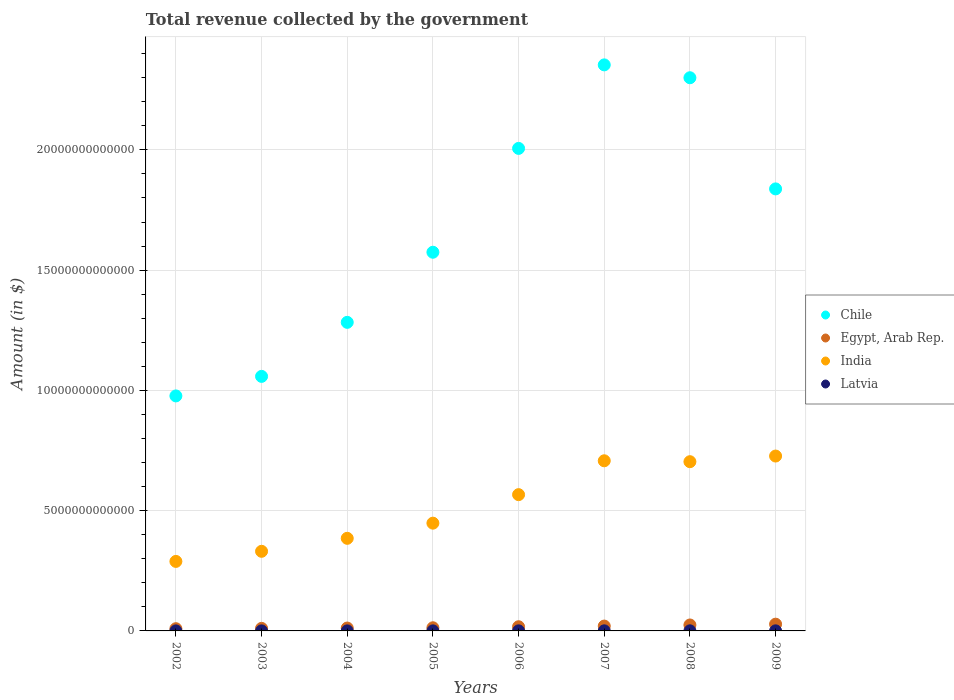How many different coloured dotlines are there?
Provide a short and direct response. 4. Is the number of dotlines equal to the number of legend labels?
Offer a very short reply. Yes. What is the total revenue collected by the government in Latvia in 2009?
Give a very brief answer. 3.39e+09. Across all years, what is the maximum total revenue collected by the government in Egypt, Arab Rep.?
Provide a succinct answer. 2.81e+11. Across all years, what is the minimum total revenue collected by the government in India?
Offer a very short reply. 2.89e+12. In which year was the total revenue collected by the government in Chile maximum?
Give a very brief answer. 2007. What is the total total revenue collected by the government in Egypt, Arab Rep. in the graph?
Your answer should be compact. 1.35e+12. What is the difference between the total revenue collected by the government in Egypt, Arab Rep. in 2002 and that in 2005?
Your response must be concise. -3.85e+1. What is the difference between the total revenue collected by the government in Latvia in 2002 and the total revenue collected by the government in Egypt, Arab Rep. in 2003?
Offer a terse response. -1.05e+11. What is the average total revenue collected by the government in Egypt, Arab Rep. per year?
Your answer should be very brief. 1.69e+11. In the year 2008, what is the difference between the total revenue collected by the government in Egypt, Arab Rep. and total revenue collected by the government in India?
Provide a short and direct response. -6.79e+12. What is the ratio of the total revenue collected by the government in Chile in 2002 to that in 2003?
Provide a succinct answer. 0.92. What is the difference between the highest and the second highest total revenue collected by the government in India?
Provide a short and direct response. 1.97e+11. What is the difference between the highest and the lowest total revenue collected by the government in Chile?
Offer a terse response. 1.38e+13. Is the sum of the total revenue collected by the government in Latvia in 2005 and 2008 greater than the maximum total revenue collected by the government in Chile across all years?
Ensure brevity in your answer.  No. Does the total revenue collected by the government in India monotonically increase over the years?
Make the answer very short. No. How many dotlines are there?
Ensure brevity in your answer.  4. What is the difference between two consecutive major ticks on the Y-axis?
Provide a succinct answer. 5.00e+12. Are the values on the major ticks of Y-axis written in scientific E-notation?
Offer a very short reply. No. How many legend labels are there?
Ensure brevity in your answer.  4. What is the title of the graph?
Provide a succinct answer. Total revenue collected by the government. What is the label or title of the Y-axis?
Your answer should be very brief. Amount (in $). What is the Amount (in $) of Chile in 2002?
Give a very brief answer. 9.77e+12. What is the Amount (in $) of Egypt, Arab Rep. in 2002?
Offer a terse response. 9.23e+1. What is the Amount (in $) in India in 2002?
Give a very brief answer. 2.89e+12. What is the Amount (in $) in Latvia in 2002?
Your response must be concise. 1.50e+09. What is the Amount (in $) in Chile in 2003?
Keep it short and to the point. 1.06e+13. What is the Amount (in $) in Egypt, Arab Rep. in 2003?
Offer a very short reply. 1.06e+11. What is the Amount (in $) in India in 2003?
Provide a short and direct response. 3.31e+12. What is the Amount (in $) of Latvia in 2003?
Ensure brevity in your answer.  1.66e+09. What is the Amount (in $) of Chile in 2004?
Provide a short and direct response. 1.28e+13. What is the Amount (in $) of Egypt, Arab Rep. in 2004?
Offer a terse response. 1.20e+11. What is the Amount (in $) in India in 2004?
Provide a succinct answer. 3.85e+12. What is the Amount (in $) of Latvia in 2004?
Your answer should be compact. 1.90e+09. What is the Amount (in $) in Chile in 2005?
Your answer should be compact. 1.57e+13. What is the Amount (in $) in Egypt, Arab Rep. in 2005?
Give a very brief answer. 1.31e+11. What is the Amount (in $) of India in 2005?
Make the answer very short. 4.48e+12. What is the Amount (in $) in Latvia in 2005?
Provide a short and direct response. 2.38e+09. What is the Amount (in $) of Chile in 2006?
Offer a terse response. 2.01e+13. What is the Amount (in $) of Egypt, Arab Rep. in 2006?
Provide a succinct answer. 1.74e+11. What is the Amount (in $) of India in 2006?
Give a very brief answer. 5.67e+12. What is the Amount (in $) in Latvia in 2006?
Offer a terse response. 3.04e+09. What is the Amount (in $) in Chile in 2007?
Your answer should be very brief. 2.35e+13. What is the Amount (in $) of Egypt, Arab Rep. in 2007?
Keep it short and to the point. 2.02e+11. What is the Amount (in $) of India in 2007?
Your answer should be very brief. 7.07e+12. What is the Amount (in $) of Latvia in 2007?
Your answer should be compact. 3.93e+09. What is the Amount (in $) in Chile in 2008?
Your response must be concise. 2.30e+13. What is the Amount (in $) of Egypt, Arab Rep. in 2008?
Your answer should be compact. 2.47e+11. What is the Amount (in $) in India in 2008?
Your answer should be very brief. 7.04e+12. What is the Amount (in $) in Latvia in 2008?
Keep it short and to the point. 4.23e+09. What is the Amount (in $) in Chile in 2009?
Your answer should be very brief. 1.84e+13. What is the Amount (in $) of Egypt, Arab Rep. in 2009?
Your answer should be very brief. 2.81e+11. What is the Amount (in $) in India in 2009?
Keep it short and to the point. 7.27e+12. What is the Amount (in $) of Latvia in 2009?
Make the answer very short. 3.39e+09. Across all years, what is the maximum Amount (in $) in Chile?
Make the answer very short. 2.35e+13. Across all years, what is the maximum Amount (in $) of Egypt, Arab Rep.?
Provide a short and direct response. 2.81e+11. Across all years, what is the maximum Amount (in $) of India?
Give a very brief answer. 7.27e+12. Across all years, what is the maximum Amount (in $) of Latvia?
Your answer should be compact. 4.23e+09. Across all years, what is the minimum Amount (in $) in Chile?
Make the answer very short. 9.77e+12. Across all years, what is the minimum Amount (in $) of Egypt, Arab Rep.?
Offer a terse response. 9.23e+1. Across all years, what is the minimum Amount (in $) of India?
Offer a terse response. 2.89e+12. Across all years, what is the minimum Amount (in $) of Latvia?
Ensure brevity in your answer.  1.50e+09. What is the total Amount (in $) in Chile in the graph?
Provide a succinct answer. 1.34e+14. What is the total Amount (in $) of Egypt, Arab Rep. in the graph?
Ensure brevity in your answer.  1.35e+12. What is the total Amount (in $) of India in the graph?
Your answer should be very brief. 4.16e+13. What is the total Amount (in $) of Latvia in the graph?
Offer a terse response. 2.20e+1. What is the difference between the Amount (in $) in Chile in 2002 and that in 2003?
Offer a very short reply. -8.12e+11. What is the difference between the Amount (in $) in Egypt, Arab Rep. in 2002 and that in 2003?
Your answer should be very brief. -1.39e+1. What is the difference between the Amount (in $) of India in 2002 and that in 2003?
Give a very brief answer. -4.20e+11. What is the difference between the Amount (in $) of Latvia in 2002 and that in 2003?
Ensure brevity in your answer.  -1.63e+08. What is the difference between the Amount (in $) in Chile in 2002 and that in 2004?
Ensure brevity in your answer.  -3.06e+12. What is the difference between the Amount (in $) in Egypt, Arab Rep. in 2002 and that in 2004?
Make the answer very short. -2.73e+1. What is the difference between the Amount (in $) of India in 2002 and that in 2004?
Offer a terse response. -9.60e+11. What is the difference between the Amount (in $) of Latvia in 2002 and that in 2004?
Provide a succinct answer. -4.00e+08. What is the difference between the Amount (in $) of Chile in 2002 and that in 2005?
Your answer should be very brief. -5.97e+12. What is the difference between the Amount (in $) in Egypt, Arab Rep. in 2002 and that in 2005?
Provide a short and direct response. -3.85e+1. What is the difference between the Amount (in $) in India in 2002 and that in 2005?
Provide a succinct answer. -1.59e+12. What is the difference between the Amount (in $) of Latvia in 2002 and that in 2005?
Provide a succinct answer. -8.79e+08. What is the difference between the Amount (in $) of Chile in 2002 and that in 2006?
Your answer should be very brief. -1.03e+13. What is the difference between the Amount (in $) of Egypt, Arab Rep. in 2002 and that in 2006?
Make the answer very short. -8.16e+1. What is the difference between the Amount (in $) in India in 2002 and that in 2006?
Your answer should be very brief. -2.78e+12. What is the difference between the Amount (in $) in Latvia in 2002 and that in 2006?
Your answer should be very brief. -1.54e+09. What is the difference between the Amount (in $) of Chile in 2002 and that in 2007?
Your answer should be very brief. -1.38e+13. What is the difference between the Amount (in $) in Egypt, Arab Rep. in 2002 and that in 2007?
Provide a succinct answer. -1.10e+11. What is the difference between the Amount (in $) of India in 2002 and that in 2007?
Keep it short and to the point. -4.18e+12. What is the difference between the Amount (in $) in Latvia in 2002 and that in 2007?
Your answer should be compact. -2.43e+09. What is the difference between the Amount (in $) of Chile in 2002 and that in 2008?
Provide a short and direct response. -1.32e+13. What is the difference between the Amount (in $) in Egypt, Arab Rep. in 2002 and that in 2008?
Offer a terse response. -1.55e+11. What is the difference between the Amount (in $) in India in 2002 and that in 2008?
Your answer should be very brief. -4.15e+12. What is the difference between the Amount (in $) in Latvia in 2002 and that in 2008?
Your answer should be very brief. -2.73e+09. What is the difference between the Amount (in $) of Chile in 2002 and that in 2009?
Your answer should be compact. -8.61e+12. What is the difference between the Amount (in $) of Egypt, Arab Rep. in 2002 and that in 2009?
Your answer should be compact. -1.88e+11. What is the difference between the Amount (in $) in India in 2002 and that in 2009?
Ensure brevity in your answer.  -4.38e+12. What is the difference between the Amount (in $) in Latvia in 2002 and that in 2009?
Provide a succinct answer. -1.89e+09. What is the difference between the Amount (in $) of Chile in 2003 and that in 2004?
Make the answer very short. -2.25e+12. What is the difference between the Amount (in $) in Egypt, Arab Rep. in 2003 and that in 2004?
Your answer should be compact. -1.34e+1. What is the difference between the Amount (in $) of India in 2003 and that in 2004?
Your answer should be compact. -5.40e+11. What is the difference between the Amount (in $) in Latvia in 2003 and that in 2004?
Provide a short and direct response. -2.37e+08. What is the difference between the Amount (in $) of Chile in 2003 and that in 2005?
Offer a terse response. -5.16e+12. What is the difference between the Amount (in $) of Egypt, Arab Rep. in 2003 and that in 2005?
Your answer should be very brief. -2.46e+1. What is the difference between the Amount (in $) in India in 2003 and that in 2005?
Offer a very short reply. -1.17e+12. What is the difference between the Amount (in $) in Latvia in 2003 and that in 2005?
Ensure brevity in your answer.  -7.15e+08. What is the difference between the Amount (in $) of Chile in 2003 and that in 2006?
Keep it short and to the point. -9.48e+12. What is the difference between the Amount (in $) in Egypt, Arab Rep. in 2003 and that in 2006?
Make the answer very short. -6.76e+1. What is the difference between the Amount (in $) in India in 2003 and that in 2006?
Your answer should be very brief. -2.36e+12. What is the difference between the Amount (in $) of Latvia in 2003 and that in 2006?
Your answer should be compact. -1.37e+09. What is the difference between the Amount (in $) in Chile in 2003 and that in 2007?
Your answer should be very brief. -1.30e+13. What is the difference between the Amount (in $) in Egypt, Arab Rep. in 2003 and that in 2007?
Your answer should be very brief. -9.58e+1. What is the difference between the Amount (in $) of India in 2003 and that in 2007?
Offer a very short reply. -3.76e+12. What is the difference between the Amount (in $) in Latvia in 2003 and that in 2007?
Your answer should be very brief. -2.26e+09. What is the difference between the Amount (in $) in Chile in 2003 and that in 2008?
Provide a short and direct response. -1.24e+13. What is the difference between the Amount (in $) of Egypt, Arab Rep. in 2003 and that in 2008?
Make the answer very short. -1.41e+11. What is the difference between the Amount (in $) of India in 2003 and that in 2008?
Keep it short and to the point. -3.73e+12. What is the difference between the Amount (in $) of Latvia in 2003 and that in 2008?
Provide a succinct answer. -2.56e+09. What is the difference between the Amount (in $) in Chile in 2003 and that in 2009?
Ensure brevity in your answer.  -7.79e+12. What is the difference between the Amount (in $) of Egypt, Arab Rep. in 2003 and that in 2009?
Offer a terse response. -1.74e+11. What is the difference between the Amount (in $) of India in 2003 and that in 2009?
Offer a terse response. -3.96e+12. What is the difference between the Amount (in $) in Latvia in 2003 and that in 2009?
Give a very brief answer. -1.72e+09. What is the difference between the Amount (in $) in Chile in 2004 and that in 2005?
Provide a short and direct response. -2.91e+12. What is the difference between the Amount (in $) in Egypt, Arab Rep. in 2004 and that in 2005?
Keep it short and to the point. -1.12e+1. What is the difference between the Amount (in $) in India in 2004 and that in 2005?
Ensure brevity in your answer.  -6.30e+11. What is the difference between the Amount (in $) of Latvia in 2004 and that in 2005?
Make the answer very short. -4.78e+08. What is the difference between the Amount (in $) in Chile in 2004 and that in 2006?
Your answer should be compact. -7.23e+12. What is the difference between the Amount (in $) of Egypt, Arab Rep. in 2004 and that in 2006?
Your response must be concise. -5.42e+1. What is the difference between the Amount (in $) in India in 2004 and that in 2006?
Offer a very short reply. -1.82e+12. What is the difference between the Amount (in $) in Latvia in 2004 and that in 2006?
Make the answer very short. -1.14e+09. What is the difference between the Amount (in $) in Chile in 2004 and that in 2007?
Offer a terse response. -1.07e+13. What is the difference between the Amount (in $) of Egypt, Arab Rep. in 2004 and that in 2007?
Give a very brief answer. -8.24e+1. What is the difference between the Amount (in $) in India in 2004 and that in 2007?
Provide a short and direct response. -3.22e+12. What is the difference between the Amount (in $) of Latvia in 2004 and that in 2007?
Make the answer very short. -2.03e+09. What is the difference between the Amount (in $) of Chile in 2004 and that in 2008?
Your answer should be compact. -1.02e+13. What is the difference between the Amount (in $) in Egypt, Arab Rep. in 2004 and that in 2008?
Ensure brevity in your answer.  -1.28e+11. What is the difference between the Amount (in $) of India in 2004 and that in 2008?
Make the answer very short. -3.19e+12. What is the difference between the Amount (in $) of Latvia in 2004 and that in 2008?
Offer a terse response. -2.33e+09. What is the difference between the Amount (in $) of Chile in 2004 and that in 2009?
Your response must be concise. -5.55e+12. What is the difference between the Amount (in $) of Egypt, Arab Rep. in 2004 and that in 2009?
Your response must be concise. -1.61e+11. What is the difference between the Amount (in $) of India in 2004 and that in 2009?
Your answer should be compact. -3.42e+12. What is the difference between the Amount (in $) in Latvia in 2004 and that in 2009?
Your answer should be compact. -1.49e+09. What is the difference between the Amount (in $) in Chile in 2005 and that in 2006?
Your answer should be very brief. -4.32e+12. What is the difference between the Amount (in $) of Egypt, Arab Rep. in 2005 and that in 2006?
Keep it short and to the point. -4.30e+1. What is the difference between the Amount (in $) of India in 2005 and that in 2006?
Keep it short and to the point. -1.19e+12. What is the difference between the Amount (in $) in Latvia in 2005 and that in 2006?
Ensure brevity in your answer.  -6.58e+08. What is the difference between the Amount (in $) in Chile in 2005 and that in 2007?
Your answer should be very brief. -7.79e+12. What is the difference between the Amount (in $) of Egypt, Arab Rep. in 2005 and that in 2007?
Your response must be concise. -7.12e+1. What is the difference between the Amount (in $) of India in 2005 and that in 2007?
Give a very brief answer. -2.59e+12. What is the difference between the Amount (in $) in Latvia in 2005 and that in 2007?
Make the answer very short. -1.55e+09. What is the difference between the Amount (in $) in Chile in 2005 and that in 2008?
Provide a short and direct response. -7.25e+12. What is the difference between the Amount (in $) of Egypt, Arab Rep. in 2005 and that in 2008?
Offer a terse response. -1.17e+11. What is the difference between the Amount (in $) in India in 2005 and that in 2008?
Provide a short and direct response. -2.56e+12. What is the difference between the Amount (in $) in Latvia in 2005 and that in 2008?
Your answer should be very brief. -1.85e+09. What is the difference between the Amount (in $) in Chile in 2005 and that in 2009?
Make the answer very short. -2.63e+12. What is the difference between the Amount (in $) in Egypt, Arab Rep. in 2005 and that in 2009?
Offer a terse response. -1.50e+11. What is the difference between the Amount (in $) of India in 2005 and that in 2009?
Make the answer very short. -2.79e+12. What is the difference between the Amount (in $) in Latvia in 2005 and that in 2009?
Provide a succinct answer. -1.01e+09. What is the difference between the Amount (in $) in Chile in 2006 and that in 2007?
Ensure brevity in your answer.  -3.47e+12. What is the difference between the Amount (in $) of Egypt, Arab Rep. in 2006 and that in 2007?
Make the answer very short. -2.82e+1. What is the difference between the Amount (in $) in India in 2006 and that in 2007?
Your answer should be compact. -1.41e+12. What is the difference between the Amount (in $) of Latvia in 2006 and that in 2007?
Your response must be concise. -8.90e+08. What is the difference between the Amount (in $) of Chile in 2006 and that in 2008?
Provide a succinct answer. -2.94e+12. What is the difference between the Amount (in $) of Egypt, Arab Rep. in 2006 and that in 2008?
Keep it short and to the point. -7.36e+1. What is the difference between the Amount (in $) of India in 2006 and that in 2008?
Your answer should be very brief. -1.37e+12. What is the difference between the Amount (in $) of Latvia in 2006 and that in 2008?
Your answer should be compact. -1.19e+09. What is the difference between the Amount (in $) of Chile in 2006 and that in 2009?
Provide a short and direct response. 1.68e+12. What is the difference between the Amount (in $) in Egypt, Arab Rep. in 2006 and that in 2009?
Make the answer very short. -1.07e+11. What is the difference between the Amount (in $) of India in 2006 and that in 2009?
Offer a terse response. -1.60e+12. What is the difference between the Amount (in $) of Latvia in 2006 and that in 2009?
Offer a very short reply. -3.51e+08. What is the difference between the Amount (in $) in Chile in 2007 and that in 2008?
Your response must be concise. 5.35e+11. What is the difference between the Amount (in $) of Egypt, Arab Rep. in 2007 and that in 2008?
Provide a succinct answer. -4.54e+1. What is the difference between the Amount (in $) in India in 2007 and that in 2008?
Offer a very short reply. 3.76e+1. What is the difference between the Amount (in $) of Latvia in 2007 and that in 2008?
Give a very brief answer. -2.99e+08. What is the difference between the Amount (in $) in Chile in 2007 and that in 2009?
Your answer should be compact. 5.16e+12. What is the difference between the Amount (in $) in Egypt, Arab Rep. in 2007 and that in 2009?
Your answer should be very brief. -7.86e+1. What is the difference between the Amount (in $) in India in 2007 and that in 2009?
Give a very brief answer. -1.97e+11. What is the difference between the Amount (in $) of Latvia in 2007 and that in 2009?
Provide a short and direct response. 5.39e+08. What is the difference between the Amount (in $) of Chile in 2008 and that in 2009?
Your answer should be compact. 4.62e+12. What is the difference between the Amount (in $) of Egypt, Arab Rep. in 2008 and that in 2009?
Make the answer very short. -3.32e+1. What is the difference between the Amount (in $) of India in 2008 and that in 2009?
Provide a succinct answer. -2.35e+11. What is the difference between the Amount (in $) of Latvia in 2008 and that in 2009?
Your answer should be very brief. 8.38e+08. What is the difference between the Amount (in $) in Chile in 2002 and the Amount (in $) in Egypt, Arab Rep. in 2003?
Give a very brief answer. 9.66e+12. What is the difference between the Amount (in $) in Chile in 2002 and the Amount (in $) in India in 2003?
Offer a very short reply. 6.46e+12. What is the difference between the Amount (in $) of Chile in 2002 and the Amount (in $) of Latvia in 2003?
Offer a very short reply. 9.77e+12. What is the difference between the Amount (in $) of Egypt, Arab Rep. in 2002 and the Amount (in $) of India in 2003?
Provide a short and direct response. -3.22e+12. What is the difference between the Amount (in $) in Egypt, Arab Rep. in 2002 and the Amount (in $) in Latvia in 2003?
Offer a very short reply. 9.06e+1. What is the difference between the Amount (in $) of India in 2002 and the Amount (in $) of Latvia in 2003?
Offer a terse response. 2.89e+12. What is the difference between the Amount (in $) of Chile in 2002 and the Amount (in $) of Egypt, Arab Rep. in 2004?
Your answer should be compact. 9.65e+12. What is the difference between the Amount (in $) in Chile in 2002 and the Amount (in $) in India in 2004?
Keep it short and to the point. 5.92e+12. What is the difference between the Amount (in $) in Chile in 2002 and the Amount (in $) in Latvia in 2004?
Make the answer very short. 9.77e+12. What is the difference between the Amount (in $) of Egypt, Arab Rep. in 2002 and the Amount (in $) of India in 2004?
Your answer should be very brief. -3.76e+12. What is the difference between the Amount (in $) in Egypt, Arab Rep. in 2002 and the Amount (in $) in Latvia in 2004?
Your answer should be very brief. 9.04e+1. What is the difference between the Amount (in $) of India in 2002 and the Amount (in $) of Latvia in 2004?
Provide a short and direct response. 2.89e+12. What is the difference between the Amount (in $) of Chile in 2002 and the Amount (in $) of Egypt, Arab Rep. in 2005?
Give a very brief answer. 9.64e+12. What is the difference between the Amount (in $) in Chile in 2002 and the Amount (in $) in India in 2005?
Make the answer very short. 5.29e+12. What is the difference between the Amount (in $) in Chile in 2002 and the Amount (in $) in Latvia in 2005?
Provide a short and direct response. 9.77e+12. What is the difference between the Amount (in $) of Egypt, Arab Rep. in 2002 and the Amount (in $) of India in 2005?
Your response must be concise. -4.39e+12. What is the difference between the Amount (in $) of Egypt, Arab Rep. in 2002 and the Amount (in $) of Latvia in 2005?
Make the answer very short. 8.99e+1. What is the difference between the Amount (in $) in India in 2002 and the Amount (in $) in Latvia in 2005?
Provide a short and direct response. 2.89e+12. What is the difference between the Amount (in $) of Chile in 2002 and the Amount (in $) of Egypt, Arab Rep. in 2006?
Give a very brief answer. 9.60e+12. What is the difference between the Amount (in $) in Chile in 2002 and the Amount (in $) in India in 2006?
Offer a terse response. 4.10e+12. What is the difference between the Amount (in $) in Chile in 2002 and the Amount (in $) in Latvia in 2006?
Your response must be concise. 9.77e+12. What is the difference between the Amount (in $) in Egypt, Arab Rep. in 2002 and the Amount (in $) in India in 2006?
Offer a very short reply. -5.57e+12. What is the difference between the Amount (in $) of Egypt, Arab Rep. in 2002 and the Amount (in $) of Latvia in 2006?
Your answer should be very brief. 8.92e+1. What is the difference between the Amount (in $) of India in 2002 and the Amount (in $) of Latvia in 2006?
Provide a short and direct response. 2.89e+12. What is the difference between the Amount (in $) of Chile in 2002 and the Amount (in $) of Egypt, Arab Rep. in 2007?
Provide a short and direct response. 9.57e+12. What is the difference between the Amount (in $) in Chile in 2002 and the Amount (in $) in India in 2007?
Provide a short and direct response. 2.70e+12. What is the difference between the Amount (in $) in Chile in 2002 and the Amount (in $) in Latvia in 2007?
Offer a very short reply. 9.77e+12. What is the difference between the Amount (in $) in Egypt, Arab Rep. in 2002 and the Amount (in $) in India in 2007?
Make the answer very short. -6.98e+12. What is the difference between the Amount (in $) of Egypt, Arab Rep. in 2002 and the Amount (in $) of Latvia in 2007?
Provide a short and direct response. 8.83e+1. What is the difference between the Amount (in $) in India in 2002 and the Amount (in $) in Latvia in 2007?
Your response must be concise. 2.89e+12. What is the difference between the Amount (in $) in Chile in 2002 and the Amount (in $) in Egypt, Arab Rep. in 2008?
Provide a short and direct response. 9.52e+12. What is the difference between the Amount (in $) of Chile in 2002 and the Amount (in $) of India in 2008?
Provide a succinct answer. 2.73e+12. What is the difference between the Amount (in $) of Chile in 2002 and the Amount (in $) of Latvia in 2008?
Provide a short and direct response. 9.77e+12. What is the difference between the Amount (in $) of Egypt, Arab Rep. in 2002 and the Amount (in $) of India in 2008?
Give a very brief answer. -6.94e+12. What is the difference between the Amount (in $) in Egypt, Arab Rep. in 2002 and the Amount (in $) in Latvia in 2008?
Ensure brevity in your answer.  8.80e+1. What is the difference between the Amount (in $) in India in 2002 and the Amount (in $) in Latvia in 2008?
Offer a terse response. 2.89e+12. What is the difference between the Amount (in $) of Chile in 2002 and the Amount (in $) of Egypt, Arab Rep. in 2009?
Offer a very short reply. 9.49e+12. What is the difference between the Amount (in $) in Chile in 2002 and the Amount (in $) in India in 2009?
Offer a terse response. 2.50e+12. What is the difference between the Amount (in $) in Chile in 2002 and the Amount (in $) in Latvia in 2009?
Provide a succinct answer. 9.77e+12. What is the difference between the Amount (in $) of Egypt, Arab Rep. in 2002 and the Amount (in $) of India in 2009?
Keep it short and to the point. -7.18e+12. What is the difference between the Amount (in $) of Egypt, Arab Rep. in 2002 and the Amount (in $) of Latvia in 2009?
Keep it short and to the point. 8.89e+1. What is the difference between the Amount (in $) in India in 2002 and the Amount (in $) in Latvia in 2009?
Ensure brevity in your answer.  2.89e+12. What is the difference between the Amount (in $) of Chile in 2003 and the Amount (in $) of Egypt, Arab Rep. in 2004?
Your response must be concise. 1.05e+13. What is the difference between the Amount (in $) of Chile in 2003 and the Amount (in $) of India in 2004?
Make the answer very short. 6.73e+12. What is the difference between the Amount (in $) of Chile in 2003 and the Amount (in $) of Latvia in 2004?
Your answer should be very brief. 1.06e+13. What is the difference between the Amount (in $) in Egypt, Arab Rep. in 2003 and the Amount (in $) in India in 2004?
Offer a terse response. -3.74e+12. What is the difference between the Amount (in $) in Egypt, Arab Rep. in 2003 and the Amount (in $) in Latvia in 2004?
Provide a succinct answer. 1.04e+11. What is the difference between the Amount (in $) of India in 2003 and the Amount (in $) of Latvia in 2004?
Give a very brief answer. 3.31e+12. What is the difference between the Amount (in $) of Chile in 2003 and the Amount (in $) of Egypt, Arab Rep. in 2005?
Give a very brief answer. 1.05e+13. What is the difference between the Amount (in $) in Chile in 2003 and the Amount (in $) in India in 2005?
Provide a short and direct response. 6.10e+12. What is the difference between the Amount (in $) in Chile in 2003 and the Amount (in $) in Latvia in 2005?
Provide a short and direct response. 1.06e+13. What is the difference between the Amount (in $) in Egypt, Arab Rep. in 2003 and the Amount (in $) in India in 2005?
Your response must be concise. -4.37e+12. What is the difference between the Amount (in $) of Egypt, Arab Rep. in 2003 and the Amount (in $) of Latvia in 2005?
Your answer should be compact. 1.04e+11. What is the difference between the Amount (in $) of India in 2003 and the Amount (in $) of Latvia in 2005?
Offer a terse response. 3.31e+12. What is the difference between the Amount (in $) of Chile in 2003 and the Amount (in $) of Egypt, Arab Rep. in 2006?
Your response must be concise. 1.04e+13. What is the difference between the Amount (in $) of Chile in 2003 and the Amount (in $) of India in 2006?
Offer a terse response. 4.92e+12. What is the difference between the Amount (in $) in Chile in 2003 and the Amount (in $) in Latvia in 2006?
Give a very brief answer. 1.06e+13. What is the difference between the Amount (in $) in Egypt, Arab Rep. in 2003 and the Amount (in $) in India in 2006?
Offer a terse response. -5.56e+12. What is the difference between the Amount (in $) in Egypt, Arab Rep. in 2003 and the Amount (in $) in Latvia in 2006?
Offer a terse response. 1.03e+11. What is the difference between the Amount (in $) in India in 2003 and the Amount (in $) in Latvia in 2006?
Offer a terse response. 3.31e+12. What is the difference between the Amount (in $) in Chile in 2003 and the Amount (in $) in Egypt, Arab Rep. in 2007?
Your answer should be very brief. 1.04e+13. What is the difference between the Amount (in $) in Chile in 2003 and the Amount (in $) in India in 2007?
Give a very brief answer. 3.51e+12. What is the difference between the Amount (in $) of Chile in 2003 and the Amount (in $) of Latvia in 2007?
Your answer should be compact. 1.06e+13. What is the difference between the Amount (in $) in Egypt, Arab Rep. in 2003 and the Amount (in $) in India in 2007?
Provide a succinct answer. -6.97e+12. What is the difference between the Amount (in $) in Egypt, Arab Rep. in 2003 and the Amount (in $) in Latvia in 2007?
Offer a terse response. 1.02e+11. What is the difference between the Amount (in $) of India in 2003 and the Amount (in $) of Latvia in 2007?
Ensure brevity in your answer.  3.31e+12. What is the difference between the Amount (in $) of Chile in 2003 and the Amount (in $) of Egypt, Arab Rep. in 2008?
Ensure brevity in your answer.  1.03e+13. What is the difference between the Amount (in $) of Chile in 2003 and the Amount (in $) of India in 2008?
Provide a succinct answer. 3.55e+12. What is the difference between the Amount (in $) of Chile in 2003 and the Amount (in $) of Latvia in 2008?
Make the answer very short. 1.06e+13. What is the difference between the Amount (in $) in Egypt, Arab Rep. in 2003 and the Amount (in $) in India in 2008?
Your answer should be compact. -6.93e+12. What is the difference between the Amount (in $) of Egypt, Arab Rep. in 2003 and the Amount (in $) of Latvia in 2008?
Keep it short and to the point. 1.02e+11. What is the difference between the Amount (in $) of India in 2003 and the Amount (in $) of Latvia in 2008?
Make the answer very short. 3.31e+12. What is the difference between the Amount (in $) of Chile in 2003 and the Amount (in $) of Egypt, Arab Rep. in 2009?
Your answer should be compact. 1.03e+13. What is the difference between the Amount (in $) in Chile in 2003 and the Amount (in $) in India in 2009?
Ensure brevity in your answer.  3.31e+12. What is the difference between the Amount (in $) in Chile in 2003 and the Amount (in $) in Latvia in 2009?
Provide a short and direct response. 1.06e+13. What is the difference between the Amount (in $) of Egypt, Arab Rep. in 2003 and the Amount (in $) of India in 2009?
Your response must be concise. -7.16e+12. What is the difference between the Amount (in $) in Egypt, Arab Rep. in 2003 and the Amount (in $) in Latvia in 2009?
Your answer should be compact. 1.03e+11. What is the difference between the Amount (in $) of India in 2003 and the Amount (in $) of Latvia in 2009?
Ensure brevity in your answer.  3.31e+12. What is the difference between the Amount (in $) of Chile in 2004 and the Amount (in $) of Egypt, Arab Rep. in 2005?
Your response must be concise. 1.27e+13. What is the difference between the Amount (in $) in Chile in 2004 and the Amount (in $) in India in 2005?
Offer a very short reply. 8.35e+12. What is the difference between the Amount (in $) in Chile in 2004 and the Amount (in $) in Latvia in 2005?
Keep it short and to the point. 1.28e+13. What is the difference between the Amount (in $) in Egypt, Arab Rep. in 2004 and the Amount (in $) in India in 2005?
Provide a short and direct response. -4.36e+12. What is the difference between the Amount (in $) in Egypt, Arab Rep. in 2004 and the Amount (in $) in Latvia in 2005?
Your answer should be very brief. 1.17e+11. What is the difference between the Amount (in $) in India in 2004 and the Amount (in $) in Latvia in 2005?
Make the answer very short. 3.85e+12. What is the difference between the Amount (in $) of Chile in 2004 and the Amount (in $) of Egypt, Arab Rep. in 2006?
Offer a terse response. 1.27e+13. What is the difference between the Amount (in $) of Chile in 2004 and the Amount (in $) of India in 2006?
Keep it short and to the point. 7.16e+12. What is the difference between the Amount (in $) of Chile in 2004 and the Amount (in $) of Latvia in 2006?
Provide a succinct answer. 1.28e+13. What is the difference between the Amount (in $) in Egypt, Arab Rep. in 2004 and the Amount (in $) in India in 2006?
Make the answer very short. -5.55e+12. What is the difference between the Amount (in $) in Egypt, Arab Rep. in 2004 and the Amount (in $) in Latvia in 2006?
Ensure brevity in your answer.  1.17e+11. What is the difference between the Amount (in $) of India in 2004 and the Amount (in $) of Latvia in 2006?
Your answer should be very brief. 3.85e+12. What is the difference between the Amount (in $) in Chile in 2004 and the Amount (in $) in Egypt, Arab Rep. in 2007?
Offer a terse response. 1.26e+13. What is the difference between the Amount (in $) of Chile in 2004 and the Amount (in $) of India in 2007?
Make the answer very short. 5.76e+12. What is the difference between the Amount (in $) of Chile in 2004 and the Amount (in $) of Latvia in 2007?
Make the answer very short. 1.28e+13. What is the difference between the Amount (in $) in Egypt, Arab Rep. in 2004 and the Amount (in $) in India in 2007?
Your answer should be very brief. -6.95e+12. What is the difference between the Amount (in $) of Egypt, Arab Rep. in 2004 and the Amount (in $) of Latvia in 2007?
Provide a short and direct response. 1.16e+11. What is the difference between the Amount (in $) in India in 2004 and the Amount (in $) in Latvia in 2007?
Give a very brief answer. 3.85e+12. What is the difference between the Amount (in $) in Chile in 2004 and the Amount (in $) in Egypt, Arab Rep. in 2008?
Your response must be concise. 1.26e+13. What is the difference between the Amount (in $) of Chile in 2004 and the Amount (in $) of India in 2008?
Your response must be concise. 5.79e+12. What is the difference between the Amount (in $) in Chile in 2004 and the Amount (in $) in Latvia in 2008?
Provide a short and direct response. 1.28e+13. What is the difference between the Amount (in $) of Egypt, Arab Rep. in 2004 and the Amount (in $) of India in 2008?
Offer a very short reply. -6.92e+12. What is the difference between the Amount (in $) of Egypt, Arab Rep. in 2004 and the Amount (in $) of Latvia in 2008?
Give a very brief answer. 1.15e+11. What is the difference between the Amount (in $) in India in 2004 and the Amount (in $) in Latvia in 2008?
Keep it short and to the point. 3.85e+12. What is the difference between the Amount (in $) of Chile in 2004 and the Amount (in $) of Egypt, Arab Rep. in 2009?
Your answer should be very brief. 1.25e+13. What is the difference between the Amount (in $) of Chile in 2004 and the Amount (in $) of India in 2009?
Offer a terse response. 5.56e+12. What is the difference between the Amount (in $) of Chile in 2004 and the Amount (in $) of Latvia in 2009?
Your answer should be very brief. 1.28e+13. What is the difference between the Amount (in $) in Egypt, Arab Rep. in 2004 and the Amount (in $) in India in 2009?
Offer a terse response. -7.15e+12. What is the difference between the Amount (in $) in Egypt, Arab Rep. in 2004 and the Amount (in $) in Latvia in 2009?
Your response must be concise. 1.16e+11. What is the difference between the Amount (in $) in India in 2004 and the Amount (in $) in Latvia in 2009?
Provide a succinct answer. 3.85e+12. What is the difference between the Amount (in $) of Chile in 2005 and the Amount (in $) of Egypt, Arab Rep. in 2006?
Your answer should be very brief. 1.56e+13. What is the difference between the Amount (in $) of Chile in 2005 and the Amount (in $) of India in 2006?
Your response must be concise. 1.01e+13. What is the difference between the Amount (in $) in Chile in 2005 and the Amount (in $) in Latvia in 2006?
Make the answer very short. 1.57e+13. What is the difference between the Amount (in $) of Egypt, Arab Rep. in 2005 and the Amount (in $) of India in 2006?
Your response must be concise. -5.53e+12. What is the difference between the Amount (in $) of Egypt, Arab Rep. in 2005 and the Amount (in $) of Latvia in 2006?
Provide a succinct answer. 1.28e+11. What is the difference between the Amount (in $) in India in 2005 and the Amount (in $) in Latvia in 2006?
Offer a very short reply. 4.48e+12. What is the difference between the Amount (in $) of Chile in 2005 and the Amount (in $) of Egypt, Arab Rep. in 2007?
Make the answer very short. 1.55e+13. What is the difference between the Amount (in $) in Chile in 2005 and the Amount (in $) in India in 2007?
Provide a succinct answer. 8.67e+12. What is the difference between the Amount (in $) of Chile in 2005 and the Amount (in $) of Latvia in 2007?
Provide a short and direct response. 1.57e+13. What is the difference between the Amount (in $) of Egypt, Arab Rep. in 2005 and the Amount (in $) of India in 2007?
Keep it short and to the point. -6.94e+12. What is the difference between the Amount (in $) in Egypt, Arab Rep. in 2005 and the Amount (in $) in Latvia in 2007?
Offer a very short reply. 1.27e+11. What is the difference between the Amount (in $) in India in 2005 and the Amount (in $) in Latvia in 2007?
Keep it short and to the point. 4.48e+12. What is the difference between the Amount (in $) in Chile in 2005 and the Amount (in $) in Egypt, Arab Rep. in 2008?
Provide a succinct answer. 1.55e+13. What is the difference between the Amount (in $) in Chile in 2005 and the Amount (in $) in India in 2008?
Provide a succinct answer. 8.71e+12. What is the difference between the Amount (in $) of Chile in 2005 and the Amount (in $) of Latvia in 2008?
Your answer should be very brief. 1.57e+13. What is the difference between the Amount (in $) of Egypt, Arab Rep. in 2005 and the Amount (in $) of India in 2008?
Your response must be concise. -6.91e+12. What is the difference between the Amount (in $) in Egypt, Arab Rep. in 2005 and the Amount (in $) in Latvia in 2008?
Ensure brevity in your answer.  1.27e+11. What is the difference between the Amount (in $) in India in 2005 and the Amount (in $) in Latvia in 2008?
Give a very brief answer. 4.48e+12. What is the difference between the Amount (in $) of Chile in 2005 and the Amount (in $) of Egypt, Arab Rep. in 2009?
Keep it short and to the point. 1.55e+13. What is the difference between the Amount (in $) of Chile in 2005 and the Amount (in $) of India in 2009?
Provide a short and direct response. 8.47e+12. What is the difference between the Amount (in $) of Chile in 2005 and the Amount (in $) of Latvia in 2009?
Offer a terse response. 1.57e+13. What is the difference between the Amount (in $) of Egypt, Arab Rep. in 2005 and the Amount (in $) of India in 2009?
Make the answer very short. -7.14e+12. What is the difference between the Amount (in $) in Egypt, Arab Rep. in 2005 and the Amount (in $) in Latvia in 2009?
Keep it short and to the point. 1.27e+11. What is the difference between the Amount (in $) in India in 2005 and the Amount (in $) in Latvia in 2009?
Keep it short and to the point. 4.48e+12. What is the difference between the Amount (in $) of Chile in 2006 and the Amount (in $) of Egypt, Arab Rep. in 2007?
Your response must be concise. 1.99e+13. What is the difference between the Amount (in $) of Chile in 2006 and the Amount (in $) of India in 2007?
Keep it short and to the point. 1.30e+13. What is the difference between the Amount (in $) of Chile in 2006 and the Amount (in $) of Latvia in 2007?
Provide a succinct answer. 2.01e+13. What is the difference between the Amount (in $) of Egypt, Arab Rep. in 2006 and the Amount (in $) of India in 2007?
Provide a short and direct response. -6.90e+12. What is the difference between the Amount (in $) of Egypt, Arab Rep. in 2006 and the Amount (in $) of Latvia in 2007?
Your answer should be very brief. 1.70e+11. What is the difference between the Amount (in $) in India in 2006 and the Amount (in $) in Latvia in 2007?
Ensure brevity in your answer.  5.66e+12. What is the difference between the Amount (in $) in Chile in 2006 and the Amount (in $) in Egypt, Arab Rep. in 2008?
Ensure brevity in your answer.  1.98e+13. What is the difference between the Amount (in $) in Chile in 2006 and the Amount (in $) in India in 2008?
Offer a very short reply. 1.30e+13. What is the difference between the Amount (in $) in Chile in 2006 and the Amount (in $) in Latvia in 2008?
Keep it short and to the point. 2.01e+13. What is the difference between the Amount (in $) of Egypt, Arab Rep. in 2006 and the Amount (in $) of India in 2008?
Make the answer very short. -6.86e+12. What is the difference between the Amount (in $) of Egypt, Arab Rep. in 2006 and the Amount (in $) of Latvia in 2008?
Keep it short and to the point. 1.70e+11. What is the difference between the Amount (in $) of India in 2006 and the Amount (in $) of Latvia in 2008?
Ensure brevity in your answer.  5.66e+12. What is the difference between the Amount (in $) of Chile in 2006 and the Amount (in $) of Egypt, Arab Rep. in 2009?
Make the answer very short. 1.98e+13. What is the difference between the Amount (in $) in Chile in 2006 and the Amount (in $) in India in 2009?
Ensure brevity in your answer.  1.28e+13. What is the difference between the Amount (in $) of Chile in 2006 and the Amount (in $) of Latvia in 2009?
Offer a very short reply. 2.01e+13. What is the difference between the Amount (in $) in Egypt, Arab Rep. in 2006 and the Amount (in $) in India in 2009?
Your response must be concise. -7.10e+12. What is the difference between the Amount (in $) in Egypt, Arab Rep. in 2006 and the Amount (in $) in Latvia in 2009?
Provide a succinct answer. 1.70e+11. What is the difference between the Amount (in $) in India in 2006 and the Amount (in $) in Latvia in 2009?
Give a very brief answer. 5.66e+12. What is the difference between the Amount (in $) in Chile in 2007 and the Amount (in $) in Egypt, Arab Rep. in 2008?
Provide a succinct answer. 2.33e+13. What is the difference between the Amount (in $) of Chile in 2007 and the Amount (in $) of India in 2008?
Offer a very short reply. 1.65e+13. What is the difference between the Amount (in $) of Chile in 2007 and the Amount (in $) of Latvia in 2008?
Your answer should be compact. 2.35e+13. What is the difference between the Amount (in $) of Egypt, Arab Rep. in 2007 and the Amount (in $) of India in 2008?
Provide a succinct answer. -6.83e+12. What is the difference between the Amount (in $) of Egypt, Arab Rep. in 2007 and the Amount (in $) of Latvia in 2008?
Ensure brevity in your answer.  1.98e+11. What is the difference between the Amount (in $) in India in 2007 and the Amount (in $) in Latvia in 2008?
Offer a terse response. 7.07e+12. What is the difference between the Amount (in $) in Chile in 2007 and the Amount (in $) in Egypt, Arab Rep. in 2009?
Provide a short and direct response. 2.33e+13. What is the difference between the Amount (in $) of Chile in 2007 and the Amount (in $) of India in 2009?
Offer a terse response. 1.63e+13. What is the difference between the Amount (in $) in Chile in 2007 and the Amount (in $) in Latvia in 2009?
Your answer should be very brief. 2.35e+13. What is the difference between the Amount (in $) of Egypt, Arab Rep. in 2007 and the Amount (in $) of India in 2009?
Ensure brevity in your answer.  -7.07e+12. What is the difference between the Amount (in $) of Egypt, Arab Rep. in 2007 and the Amount (in $) of Latvia in 2009?
Make the answer very short. 1.99e+11. What is the difference between the Amount (in $) in India in 2007 and the Amount (in $) in Latvia in 2009?
Keep it short and to the point. 7.07e+12. What is the difference between the Amount (in $) in Chile in 2008 and the Amount (in $) in Egypt, Arab Rep. in 2009?
Offer a very short reply. 2.27e+13. What is the difference between the Amount (in $) of Chile in 2008 and the Amount (in $) of India in 2009?
Offer a terse response. 1.57e+13. What is the difference between the Amount (in $) in Chile in 2008 and the Amount (in $) in Latvia in 2009?
Your answer should be compact. 2.30e+13. What is the difference between the Amount (in $) in Egypt, Arab Rep. in 2008 and the Amount (in $) in India in 2009?
Offer a very short reply. -7.02e+12. What is the difference between the Amount (in $) in Egypt, Arab Rep. in 2008 and the Amount (in $) in Latvia in 2009?
Your response must be concise. 2.44e+11. What is the difference between the Amount (in $) in India in 2008 and the Amount (in $) in Latvia in 2009?
Offer a terse response. 7.03e+12. What is the average Amount (in $) of Chile per year?
Provide a succinct answer. 1.67e+13. What is the average Amount (in $) in Egypt, Arab Rep. per year?
Offer a terse response. 1.69e+11. What is the average Amount (in $) of India per year?
Provide a succinct answer. 5.20e+12. What is the average Amount (in $) in Latvia per year?
Offer a very short reply. 2.75e+09. In the year 2002, what is the difference between the Amount (in $) in Chile and Amount (in $) in Egypt, Arab Rep.?
Your answer should be compact. 9.68e+12. In the year 2002, what is the difference between the Amount (in $) of Chile and Amount (in $) of India?
Your answer should be compact. 6.88e+12. In the year 2002, what is the difference between the Amount (in $) of Chile and Amount (in $) of Latvia?
Your answer should be very brief. 9.77e+12. In the year 2002, what is the difference between the Amount (in $) in Egypt, Arab Rep. and Amount (in $) in India?
Keep it short and to the point. -2.80e+12. In the year 2002, what is the difference between the Amount (in $) of Egypt, Arab Rep. and Amount (in $) of Latvia?
Make the answer very short. 9.08e+1. In the year 2002, what is the difference between the Amount (in $) in India and Amount (in $) in Latvia?
Your answer should be very brief. 2.89e+12. In the year 2003, what is the difference between the Amount (in $) in Chile and Amount (in $) in Egypt, Arab Rep.?
Your answer should be compact. 1.05e+13. In the year 2003, what is the difference between the Amount (in $) in Chile and Amount (in $) in India?
Give a very brief answer. 7.27e+12. In the year 2003, what is the difference between the Amount (in $) in Chile and Amount (in $) in Latvia?
Keep it short and to the point. 1.06e+13. In the year 2003, what is the difference between the Amount (in $) of Egypt, Arab Rep. and Amount (in $) of India?
Your response must be concise. -3.20e+12. In the year 2003, what is the difference between the Amount (in $) in Egypt, Arab Rep. and Amount (in $) in Latvia?
Give a very brief answer. 1.05e+11. In the year 2003, what is the difference between the Amount (in $) in India and Amount (in $) in Latvia?
Your answer should be very brief. 3.31e+12. In the year 2004, what is the difference between the Amount (in $) in Chile and Amount (in $) in Egypt, Arab Rep.?
Ensure brevity in your answer.  1.27e+13. In the year 2004, what is the difference between the Amount (in $) in Chile and Amount (in $) in India?
Your response must be concise. 8.98e+12. In the year 2004, what is the difference between the Amount (in $) of Chile and Amount (in $) of Latvia?
Ensure brevity in your answer.  1.28e+13. In the year 2004, what is the difference between the Amount (in $) of Egypt, Arab Rep. and Amount (in $) of India?
Give a very brief answer. -3.73e+12. In the year 2004, what is the difference between the Amount (in $) of Egypt, Arab Rep. and Amount (in $) of Latvia?
Provide a short and direct response. 1.18e+11. In the year 2004, what is the difference between the Amount (in $) of India and Amount (in $) of Latvia?
Provide a succinct answer. 3.85e+12. In the year 2005, what is the difference between the Amount (in $) of Chile and Amount (in $) of Egypt, Arab Rep.?
Ensure brevity in your answer.  1.56e+13. In the year 2005, what is the difference between the Amount (in $) in Chile and Amount (in $) in India?
Provide a short and direct response. 1.13e+13. In the year 2005, what is the difference between the Amount (in $) in Chile and Amount (in $) in Latvia?
Your answer should be very brief. 1.57e+13. In the year 2005, what is the difference between the Amount (in $) of Egypt, Arab Rep. and Amount (in $) of India?
Ensure brevity in your answer.  -4.35e+12. In the year 2005, what is the difference between the Amount (in $) of Egypt, Arab Rep. and Amount (in $) of Latvia?
Give a very brief answer. 1.28e+11. In the year 2005, what is the difference between the Amount (in $) of India and Amount (in $) of Latvia?
Provide a succinct answer. 4.48e+12. In the year 2006, what is the difference between the Amount (in $) in Chile and Amount (in $) in Egypt, Arab Rep.?
Make the answer very short. 1.99e+13. In the year 2006, what is the difference between the Amount (in $) in Chile and Amount (in $) in India?
Your response must be concise. 1.44e+13. In the year 2006, what is the difference between the Amount (in $) in Chile and Amount (in $) in Latvia?
Your response must be concise. 2.01e+13. In the year 2006, what is the difference between the Amount (in $) of Egypt, Arab Rep. and Amount (in $) of India?
Give a very brief answer. -5.49e+12. In the year 2006, what is the difference between the Amount (in $) of Egypt, Arab Rep. and Amount (in $) of Latvia?
Your answer should be compact. 1.71e+11. In the year 2006, what is the difference between the Amount (in $) of India and Amount (in $) of Latvia?
Provide a short and direct response. 5.66e+12. In the year 2007, what is the difference between the Amount (in $) in Chile and Amount (in $) in Egypt, Arab Rep.?
Your response must be concise. 2.33e+13. In the year 2007, what is the difference between the Amount (in $) of Chile and Amount (in $) of India?
Your answer should be compact. 1.65e+13. In the year 2007, what is the difference between the Amount (in $) of Chile and Amount (in $) of Latvia?
Your answer should be very brief. 2.35e+13. In the year 2007, what is the difference between the Amount (in $) of Egypt, Arab Rep. and Amount (in $) of India?
Keep it short and to the point. -6.87e+12. In the year 2007, what is the difference between the Amount (in $) of Egypt, Arab Rep. and Amount (in $) of Latvia?
Make the answer very short. 1.98e+11. In the year 2007, what is the difference between the Amount (in $) of India and Amount (in $) of Latvia?
Provide a short and direct response. 7.07e+12. In the year 2008, what is the difference between the Amount (in $) of Chile and Amount (in $) of Egypt, Arab Rep.?
Your answer should be very brief. 2.28e+13. In the year 2008, what is the difference between the Amount (in $) of Chile and Amount (in $) of India?
Ensure brevity in your answer.  1.60e+13. In the year 2008, what is the difference between the Amount (in $) in Chile and Amount (in $) in Latvia?
Offer a very short reply. 2.30e+13. In the year 2008, what is the difference between the Amount (in $) in Egypt, Arab Rep. and Amount (in $) in India?
Give a very brief answer. -6.79e+12. In the year 2008, what is the difference between the Amount (in $) in Egypt, Arab Rep. and Amount (in $) in Latvia?
Provide a succinct answer. 2.43e+11. In the year 2008, what is the difference between the Amount (in $) of India and Amount (in $) of Latvia?
Your answer should be compact. 7.03e+12. In the year 2009, what is the difference between the Amount (in $) of Chile and Amount (in $) of Egypt, Arab Rep.?
Offer a very short reply. 1.81e+13. In the year 2009, what is the difference between the Amount (in $) in Chile and Amount (in $) in India?
Offer a terse response. 1.11e+13. In the year 2009, what is the difference between the Amount (in $) of Chile and Amount (in $) of Latvia?
Ensure brevity in your answer.  1.84e+13. In the year 2009, what is the difference between the Amount (in $) of Egypt, Arab Rep. and Amount (in $) of India?
Provide a short and direct response. -6.99e+12. In the year 2009, what is the difference between the Amount (in $) in Egypt, Arab Rep. and Amount (in $) in Latvia?
Make the answer very short. 2.77e+11. In the year 2009, what is the difference between the Amount (in $) in India and Amount (in $) in Latvia?
Your answer should be very brief. 7.27e+12. What is the ratio of the Amount (in $) of Chile in 2002 to that in 2003?
Keep it short and to the point. 0.92. What is the ratio of the Amount (in $) of Egypt, Arab Rep. in 2002 to that in 2003?
Keep it short and to the point. 0.87. What is the ratio of the Amount (in $) in India in 2002 to that in 2003?
Offer a terse response. 0.87. What is the ratio of the Amount (in $) of Latvia in 2002 to that in 2003?
Provide a short and direct response. 0.9. What is the ratio of the Amount (in $) of Chile in 2002 to that in 2004?
Give a very brief answer. 0.76. What is the ratio of the Amount (in $) in Egypt, Arab Rep. in 2002 to that in 2004?
Keep it short and to the point. 0.77. What is the ratio of the Amount (in $) of India in 2002 to that in 2004?
Provide a short and direct response. 0.75. What is the ratio of the Amount (in $) in Latvia in 2002 to that in 2004?
Offer a very short reply. 0.79. What is the ratio of the Amount (in $) in Chile in 2002 to that in 2005?
Give a very brief answer. 0.62. What is the ratio of the Amount (in $) in Egypt, Arab Rep. in 2002 to that in 2005?
Ensure brevity in your answer.  0.71. What is the ratio of the Amount (in $) in India in 2002 to that in 2005?
Make the answer very short. 0.65. What is the ratio of the Amount (in $) in Latvia in 2002 to that in 2005?
Ensure brevity in your answer.  0.63. What is the ratio of the Amount (in $) of Chile in 2002 to that in 2006?
Provide a short and direct response. 0.49. What is the ratio of the Amount (in $) of Egypt, Arab Rep. in 2002 to that in 2006?
Ensure brevity in your answer.  0.53. What is the ratio of the Amount (in $) in India in 2002 to that in 2006?
Your answer should be very brief. 0.51. What is the ratio of the Amount (in $) of Latvia in 2002 to that in 2006?
Your answer should be very brief. 0.49. What is the ratio of the Amount (in $) of Chile in 2002 to that in 2007?
Provide a short and direct response. 0.42. What is the ratio of the Amount (in $) of Egypt, Arab Rep. in 2002 to that in 2007?
Offer a terse response. 0.46. What is the ratio of the Amount (in $) of India in 2002 to that in 2007?
Ensure brevity in your answer.  0.41. What is the ratio of the Amount (in $) of Latvia in 2002 to that in 2007?
Provide a succinct answer. 0.38. What is the ratio of the Amount (in $) of Chile in 2002 to that in 2008?
Offer a very short reply. 0.42. What is the ratio of the Amount (in $) in Egypt, Arab Rep. in 2002 to that in 2008?
Provide a short and direct response. 0.37. What is the ratio of the Amount (in $) in India in 2002 to that in 2008?
Keep it short and to the point. 0.41. What is the ratio of the Amount (in $) in Latvia in 2002 to that in 2008?
Your response must be concise. 0.36. What is the ratio of the Amount (in $) of Chile in 2002 to that in 2009?
Offer a very short reply. 0.53. What is the ratio of the Amount (in $) of Egypt, Arab Rep. in 2002 to that in 2009?
Provide a succinct answer. 0.33. What is the ratio of the Amount (in $) of India in 2002 to that in 2009?
Offer a very short reply. 0.4. What is the ratio of the Amount (in $) in Latvia in 2002 to that in 2009?
Ensure brevity in your answer.  0.44. What is the ratio of the Amount (in $) of Chile in 2003 to that in 2004?
Make the answer very short. 0.82. What is the ratio of the Amount (in $) in Egypt, Arab Rep. in 2003 to that in 2004?
Offer a terse response. 0.89. What is the ratio of the Amount (in $) in India in 2003 to that in 2004?
Keep it short and to the point. 0.86. What is the ratio of the Amount (in $) of Latvia in 2003 to that in 2004?
Offer a very short reply. 0.88. What is the ratio of the Amount (in $) in Chile in 2003 to that in 2005?
Ensure brevity in your answer.  0.67. What is the ratio of the Amount (in $) in Egypt, Arab Rep. in 2003 to that in 2005?
Give a very brief answer. 0.81. What is the ratio of the Amount (in $) in India in 2003 to that in 2005?
Give a very brief answer. 0.74. What is the ratio of the Amount (in $) in Latvia in 2003 to that in 2005?
Give a very brief answer. 0.7. What is the ratio of the Amount (in $) of Chile in 2003 to that in 2006?
Your answer should be very brief. 0.53. What is the ratio of the Amount (in $) in Egypt, Arab Rep. in 2003 to that in 2006?
Provide a succinct answer. 0.61. What is the ratio of the Amount (in $) of India in 2003 to that in 2006?
Provide a succinct answer. 0.58. What is the ratio of the Amount (in $) in Latvia in 2003 to that in 2006?
Your answer should be compact. 0.55. What is the ratio of the Amount (in $) of Chile in 2003 to that in 2007?
Offer a terse response. 0.45. What is the ratio of the Amount (in $) in Egypt, Arab Rep. in 2003 to that in 2007?
Offer a terse response. 0.53. What is the ratio of the Amount (in $) in India in 2003 to that in 2007?
Your answer should be very brief. 0.47. What is the ratio of the Amount (in $) of Latvia in 2003 to that in 2007?
Your answer should be very brief. 0.42. What is the ratio of the Amount (in $) of Chile in 2003 to that in 2008?
Your response must be concise. 0.46. What is the ratio of the Amount (in $) of Egypt, Arab Rep. in 2003 to that in 2008?
Provide a short and direct response. 0.43. What is the ratio of the Amount (in $) in India in 2003 to that in 2008?
Offer a very short reply. 0.47. What is the ratio of the Amount (in $) of Latvia in 2003 to that in 2008?
Give a very brief answer. 0.39. What is the ratio of the Amount (in $) of Chile in 2003 to that in 2009?
Give a very brief answer. 0.58. What is the ratio of the Amount (in $) of Egypt, Arab Rep. in 2003 to that in 2009?
Keep it short and to the point. 0.38. What is the ratio of the Amount (in $) in India in 2003 to that in 2009?
Offer a very short reply. 0.46. What is the ratio of the Amount (in $) in Latvia in 2003 to that in 2009?
Offer a terse response. 0.49. What is the ratio of the Amount (in $) in Chile in 2004 to that in 2005?
Provide a succinct answer. 0.81. What is the ratio of the Amount (in $) of Egypt, Arab Rep. in 2004 to that in 2005?
Keep it short and to the point. 0.91. What is the ratio of the Amount (in $) in India in 2004 to that in 2005?
Your response must be concise. 0.86. What is the ratio of the Amount (in $) in Latvia in 2004 to that in 2005?
Keep it short and to the point. 0.8. What is the ratio of the Amount (in $) of Chile in 2004 to that in 2006?
Your response must be concise. 0.64. What is the ratio of the Amount (in $) of Egypt, Arab Rep. in 2004 to that in 2006?
Your answer should be very brief. 0.69. What is the ratio of the Amount (in $) in India in 2004 to that in 2006?
Offer a very short reply. 0.68. What is the ratio of the Amount (in $) in Latvia in 2004 to that in 2006?
Provide a short and direct response. 0.63. What is the ratio of the Amount (in $) of Chile in 2004 to that in 2007?
Your answer should be compact. 0.55. What is the ratio of the Amount (in $) of Egypt, Arab Rep. in 2004 to that in 2007?
Make the answer very short. 0.59. What is the ratio of the Amount (in $) in India in 2004 to that in 2007?
Your answer should be compact. 0.54. What is the ratio of the Amount (in $) in Latvia in 2004 to that in 2007?
Keep it short and to the point. 0.48. What is the ratio of the Amount (in $) of Chile in 2004 to that in 2008?
Offer a very short reply. 0.56. What is the ratio of the Amount (in $) in Egypt, Arab Rep. in 2004 to that in 2008?
Your response must be concise. 0.48. What is the ratio of the Amount (in $) in India in 2004 to that in 2008?
Make the answer very short. 0.55. What is the ratio of the Amount (in $) of Latvia in 2004 to that in 2008?
Provide a short and direct response. 0.45. What is the ratio of the Amount (in $) in Chile in 2004 to that in 2009?
Ensure brevity in your answer.  0.7. What is the ratio of the Amount (in $) in Egypt, Arab Rep. in 2004 to that in 2009?
Your answer should be very brief. 0.43. What is the ratio of the Amount (in $) in India in 2004 to that in 2009?
Your answer should be very brief. 0.53. What is the ratio of the Amount (in $) of Latvia in 2004 to that in 2009?
Your answer should be compact. 0.56. What is the ratio of the Amount (in $) in Chile in 2005 to that in 2006?
Make the answer very short. 0.78. What is the ratio of the Amount (in $) of Egypt, Arab Rep. in 2005 to that in 2006?
Offer a terse response. 0.75. What is the ratio of the Amount (in $) in India in 2005 to that in 2006?
Provide a short and direct response. 0.79. What is the ratio of the Amount (in $) of Latvia in 2005 to that in 2006?
Make the answer very short. 0.78. What is the ratio of the Amount (in $) of Chile in 2005 to that in 2007?
Your response must be concise. 0.67. What is the ratio of the Amount (in $) of Egypt, Arab Rep. in 2005 to that in 2007?
Provide a succinct answer. 0.65. What is the ratio of the Amount (in $) in India in 2005 to that in 2007?
Offer a very short reply. 0.63. What is the ratio of the Amount (in $) of Latvia in 2005 to that in 2007?
Provide a succinct answer. 0.61. What is the ratio of the Amount (in $) of Chile in 2005 to that in 2008?
Give a very brief answer. 0.68. What is the ratio of the Amount (in $) of Egypt, Arab Rep. in 2005 to that in 2008?
Provide a short and direct response. 0.53. What is the ratio of the Amount (in $) of India in 2005 to that in 2008?
Offer a very short reply. 0.64. What is the ratio of the Amount (in $) of Latvia in 2005 to that in 2008?
Provide a succinct answer. 0.56. What is the ratio of the Amount (in $) of Chile in 2005 to that in 2009?
Ensure brevity in your answer.  0.86. What is the ratio of the Amount (in $) of Egypt, Arab Rep. in 2005 to that in 2009?
Give a very brief answer. 0.47. What is the ratio of the Amount (in $) of India in 2005 to that in 2009?
Your answer should be compact. 0.62. What is the ratio of the Amount (in $) of Latvia in 2005 to that in 2009?
Provide a succinct answer. 0.7. What is the ratio of the Amount (in $) in Chile in 2006 to that in 2007?
Keep it short and to the point. 0.85. What is the ratio of the Amount (in $) of Egypt, Arab Rep. in 2006 to that in 2007?
Your answer should be very brief. 0.86. What is the ratio of the Amount (in $) of India in 2006 to that in 2007?
Offer a very short reply. 0.8. What is the ratio of the Amount (in $) in Latvia in 2006 to that in 2007?
Your answer should be compact. 0.77. What is the ratio of the Amount (in $) of Chile in 2006 to that in 2008?
Your response must be concise. 0.87. What is the ratio of the Amount (in $) of Egypt, Arab Rep. in 2006 to that in 2008?
Keep it short and to the point. 0.7. What is the ratio of the Amount (in $) of India in 2006 to that in 2008?
Your answer should be very brief. 0.81. What is the ratio of the Amount (in $) in Latvia in 2006 to that in 2008?
Your answer should be compact. 0.72. What is the ratio of the Amount (in $) in Chile in 2006 to that in 2009?
Ensure brevity in your answer.  1.09. What is the ratio of the Amount (in $) of Egypt, Arab Rep. in 2006 to that in 2009?
Your answer should be very brief. 0.62. What is the ratio of the Amount (in $) in India in 2006 to that in 2009?
Offer a terse response. 0.78. What is the ratio of the Amount (in $) of Latvia in 2006 to that in 2009?
Your answer should be very brief. 0.9. What is the ratio of the Amount (in $) in Chile in 2007 to that in 2008?
Ensure brevity in your answer.  1.02. What is the ratio of the Amount (in $) of Egypt, Arab Rep. in 2007 to that in 2008?
Your answer should be compact. 0.82. What is the ratio of the Amount (in $) in India in 2007 to that in 2008?
Make the answer very short. 1.01. What is the ratio of the Amount (in $) in Latvia in 2007 to that in 2008?
Offer a very short reply. 0.93. What is the ratio of the Amount (in $) in Chile in 2007 to that in 2009?
Offer a terse response. 1.28. What is the ratio of the Amount (in $) of Egypt, Arab Rep. in 2007 to that in 2009?
Offer a terse response. 0.72. What is the ratio of the Amount (in $) of India in 2007 to that in 2009?
Give a very brief answer. 0.97. What is the ratio of the Amount (in $) in Latvia in 2007 to that in 2009?
Provide a succinct answer. 1.16. What is the ratio of the Amount (in $) of Chile in 2008 to that in 2009?
Offer a terse response. 1.25. What is the ratio of the Amount (in $) in Egypt, Arab Rep. in 2008 to that in 2009?
Make the answer very short. 0.88. What is the ratio of the Amount (in $) of Latvia in 2008 to that in 2009?
Provide a short and direct response. 1.25. What is the difference between the highest and the second highest Amount (in $) of Chile?
Provide a short and direct response. 5.35e+11. What is the difference between the highest and the second highest Amount (in $) in Egypt, Arab Rep.?
Ensure brevity in your answer.  3.32e+1. What is the difference between the highest and the second highest Amount (in $) in India?
Ensure brevity in your answer.  1.97e+11. What is the difference between the highest and the second highest Amount (in $) in Latvia?
Offer a terse response. 2.99e+08. What is the difference between the highest and the lowest Amount (in $) of Chile?
Ensure brevity in your answer.  1.38e+13. What is the difference between the highest and the lowest Amount (in $) of Egypt, Arab Rep.?
Your answer should be compact. 1.88e+11. What is the difference between the highest and the lowest Amount (in $) of India?
Ensure brevity in your answer.  4.38e+12. What is the difference between the highest and the lowest Amount (in $) in Latvia?
Your response must be concise. 2.73e+09. 